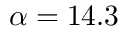<formula> <loc_0><loc_0><loc_500><loc_500>\alpha = 1 4 . 3</formula> 